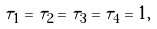Convert formula to latex. <formula><loc_0><loc_0><loc_500><loc_500>\tau _ { 1 } = \tau _ { 2 } = \tau _ { 3 } = \tau _ { 4 } = 1 ,</formula> 